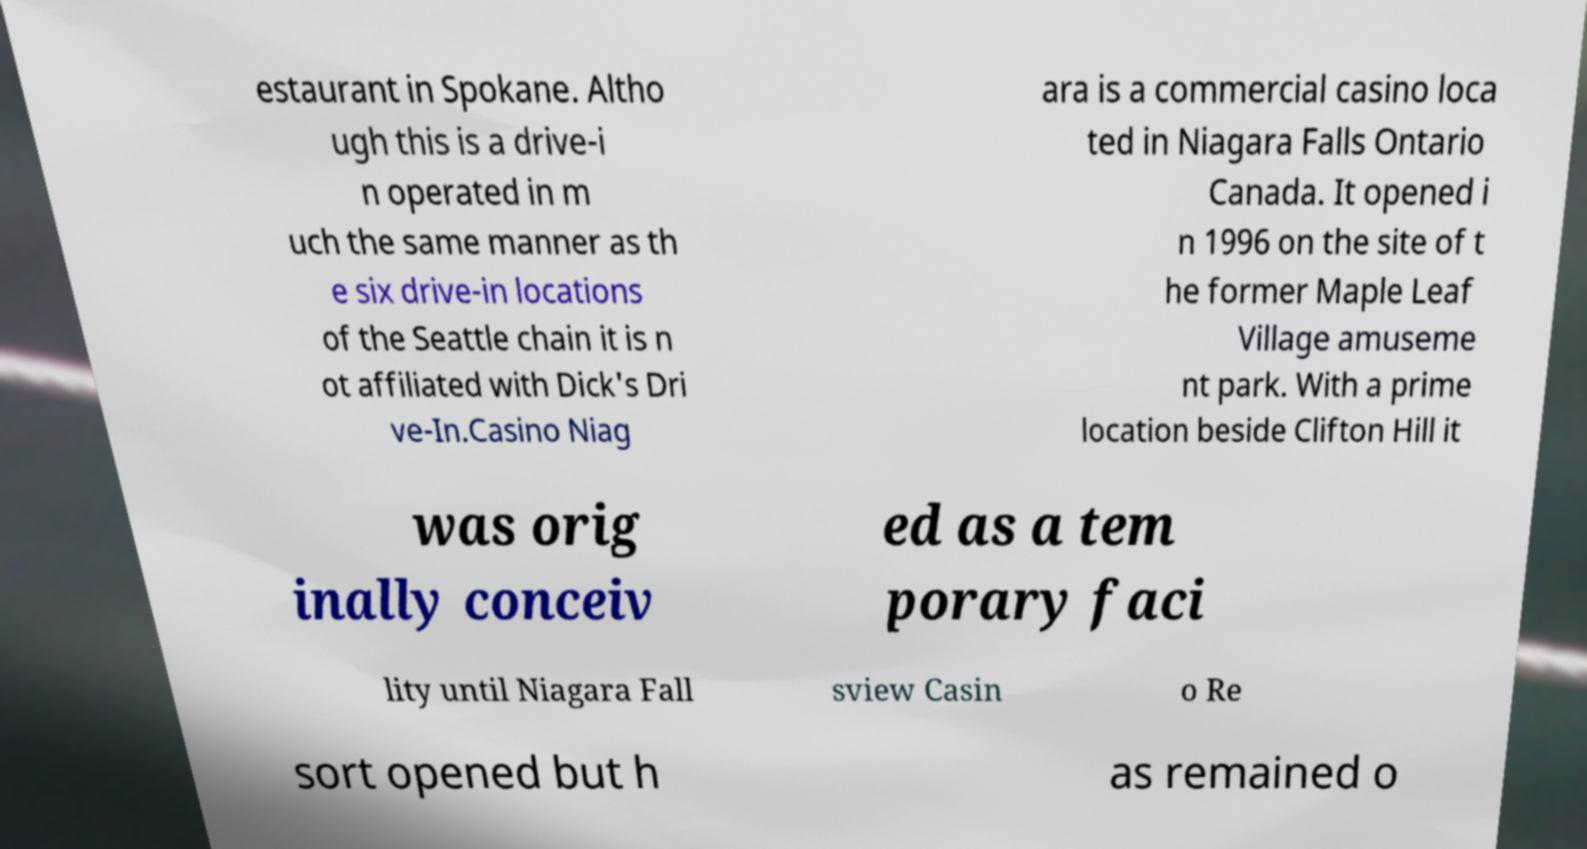What messages or text are displayed in this image? I need them in a readable, typed format. estaurant in Spokane. Altho ugh this is a drive-i n operated in m uch the same manner as th e six drive-in locations of the Seattle chain it is n ot affiliated with Dick's Dri ve-In.Casino Niag ara is a commercial casino loca ted in Niagara Falls Ontario Canada. It opened i n 1996 on the site of t he former Maple Leaf Village amuseme nt park. With a prime location beside Clifton Hill it was orig inally conceiv ed as a tem porary faci lity until Niagara Fall sview Casin o Re sort opened but h as remained o 